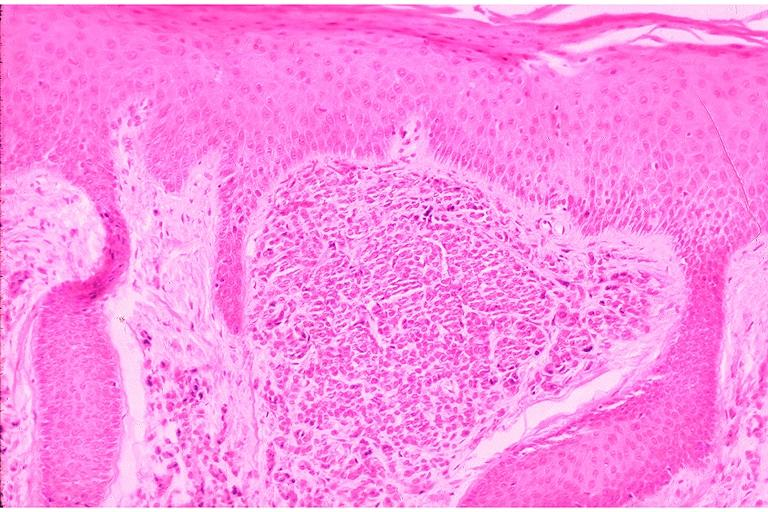s oral present?
Answer the question using a single word or phrase. Yes 